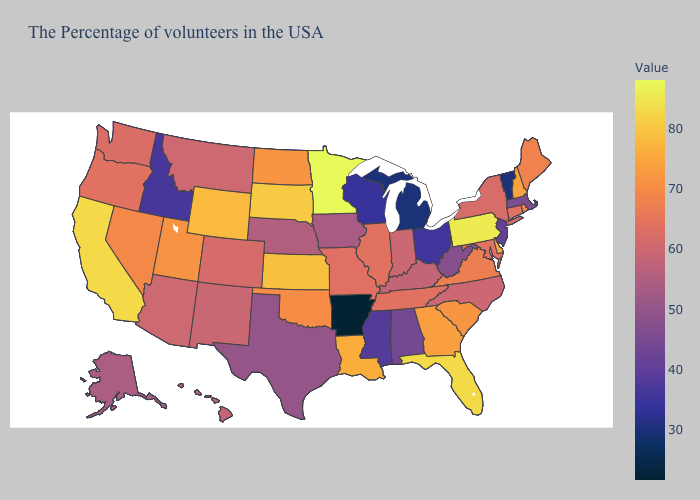Does Louisiana have a lower value than California?
Quick response, please. Yes. Which states hav the highest value in the West?
Quick response, please. California. Which states have the lowest value in the West?
Quick response, please. Idaho. Is the legend a continuous bar?
Short answer required. Yes. Which states have the lowest value in the Northeast?
Short answer required. Vermont. 